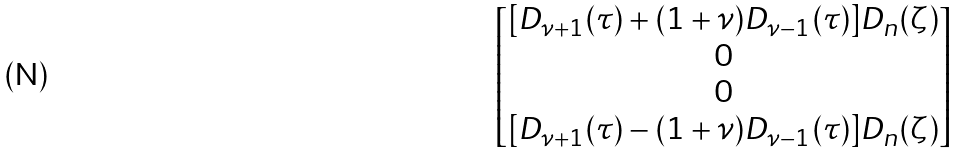Convert formula to latex. <formula><loc_0><loc_0><loc_500><loc_500>\begin{bmatrix} [ D _ { \nu + 1 } ( \tau ) + ( 1 + \nu ) D _ { \nu - 1 } ( \tau ) ] D _ { n } ( \zeta ) \\ 0 \\ 0 \\ [ D _ { \nu + 1 } ( \tau ) - ( 1 + \nu ) D _ { \nu - 1 } ( \tau ) ] D _ { n } ( \zeta ) \end{bmatrix}</formula> 